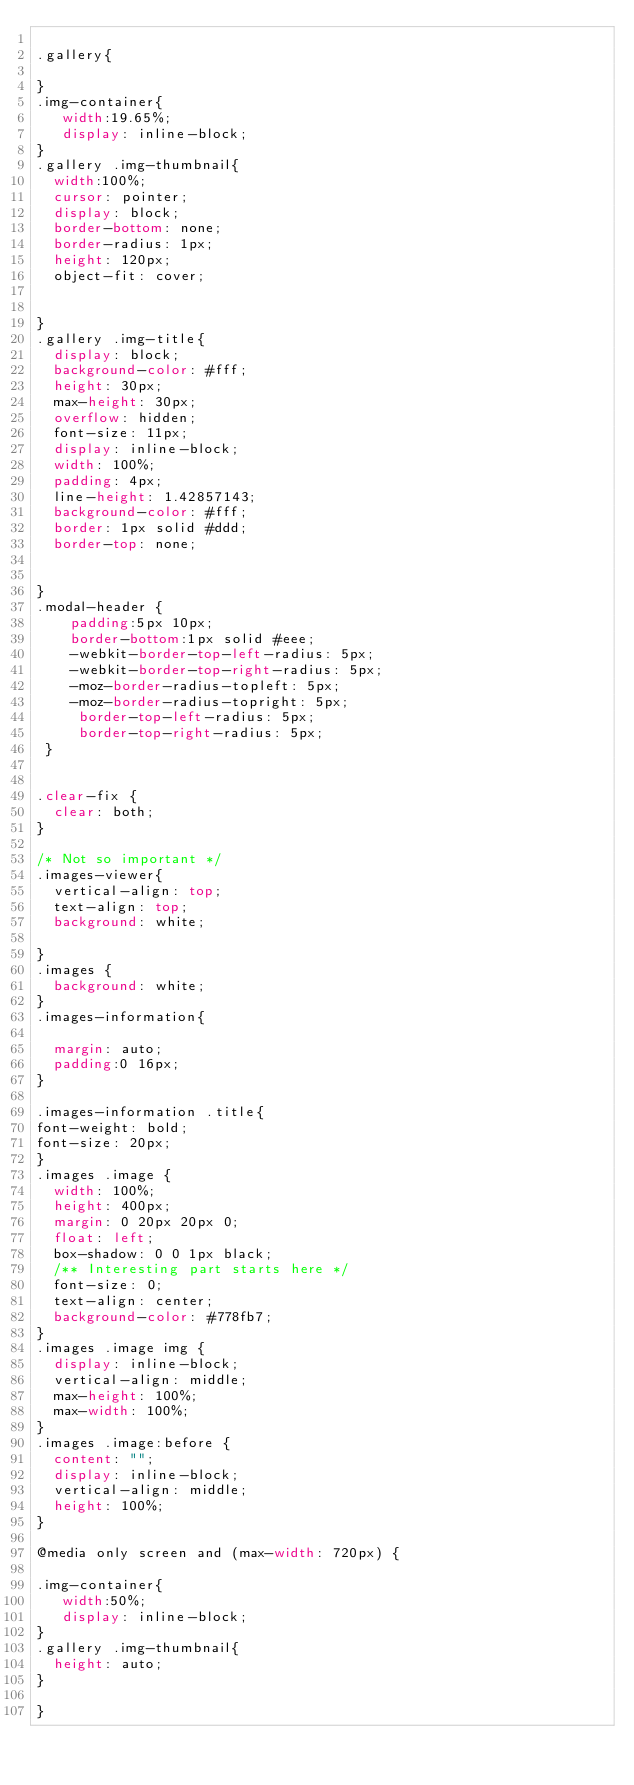Convert code to text. <code><loc_0><loc_0><loc_500><loc_500><_CSS_>  
.gallery{

}
.img-container{
   width:19.65%;
   display: inline-block;
}
.gallery .img-thumbnail{
  width:100%;
  cursor: pointer;
  display: block;
  border-bottom: none;
  border-radius: 1px;
  height: 120px;
  object-fit: cover;


}
.gallery .img-title{
  display: block;
  background-color: #fff;
  height: 30px;
  max-height: 30px;
  overflow: hidden;
  font-size: 11px;
  display: inline-block;
  width: 100%;
  padding: 4px;
  line-height: 1.42857143;
  background-color: #fff;
  border: 1px solid #ddd;
  border-top: none;


}
.modal-header {
    padding:5px 10px;
    border-bottom:1px solid #eee;
    -webkit-border-top-left-radius: 5px;
    -webkit-border-top-right-radius: 5px;
    -moz-border-radius-topleft: 5px;
    -moz-border-radius-topright: 5px;
     border-top-left-radius: 5px;
     border-top-right-radius: 5px;
 }


.clear-fix {
  clear: both;
}

/* Not so important */
.images-viewer{
  vertical-align: top;
  text-align: top;
  background: white;

}
.images {
  background: white;
}
.images-information{

  margin: auto;
  padding:0 16px;
}

.images-information .title{
font-weight: bold;
font-size: 20px;
}
.images .image {
  width: 100%;
  height: 400px;
  margin: 0 20px 20px 0;
  float: left;
  box-shadow: 0 0 1px black;
  /** Interesting part starts here */
  font-size: 0;
  text-align: center;
  background-color: #778fb7;
}
.images .image img {
  display: inline-block;
  vertical-align: middle;
  max-height: 100%;
  max-width: 100%;
}
.images .image:before {
  content: "";
  display: inline-block;
  vertical-align: middle;
  height: 100%;
}

@media only screen and (max-width: 720px) {
 
.img-container{
   width:50%;
   display: inline-block;
}
.gallery .img-thumbnail{
  height: auto;
}

}
</code> 